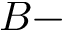<formula> <loc_0><loc_0><loc_500><loc_500>B -</formula> 